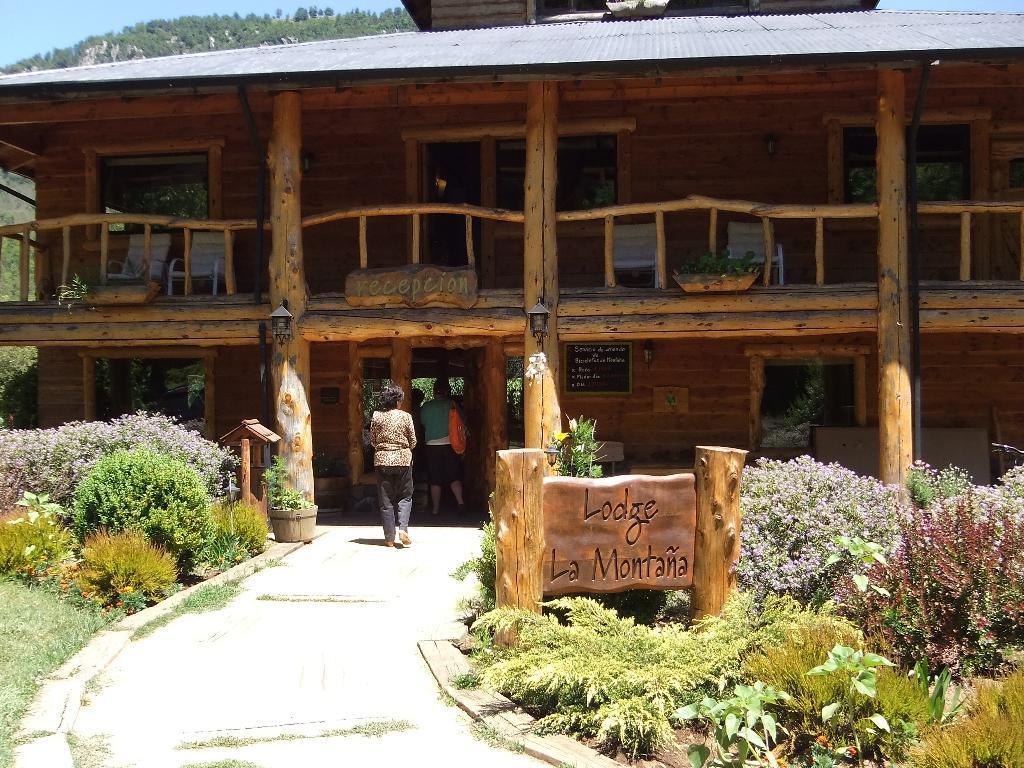What's the name on the sign?
Ensure brevity in your answer.  Lodge la montana. Where is the hotel located?
Your answer should be very brief. Montana. 